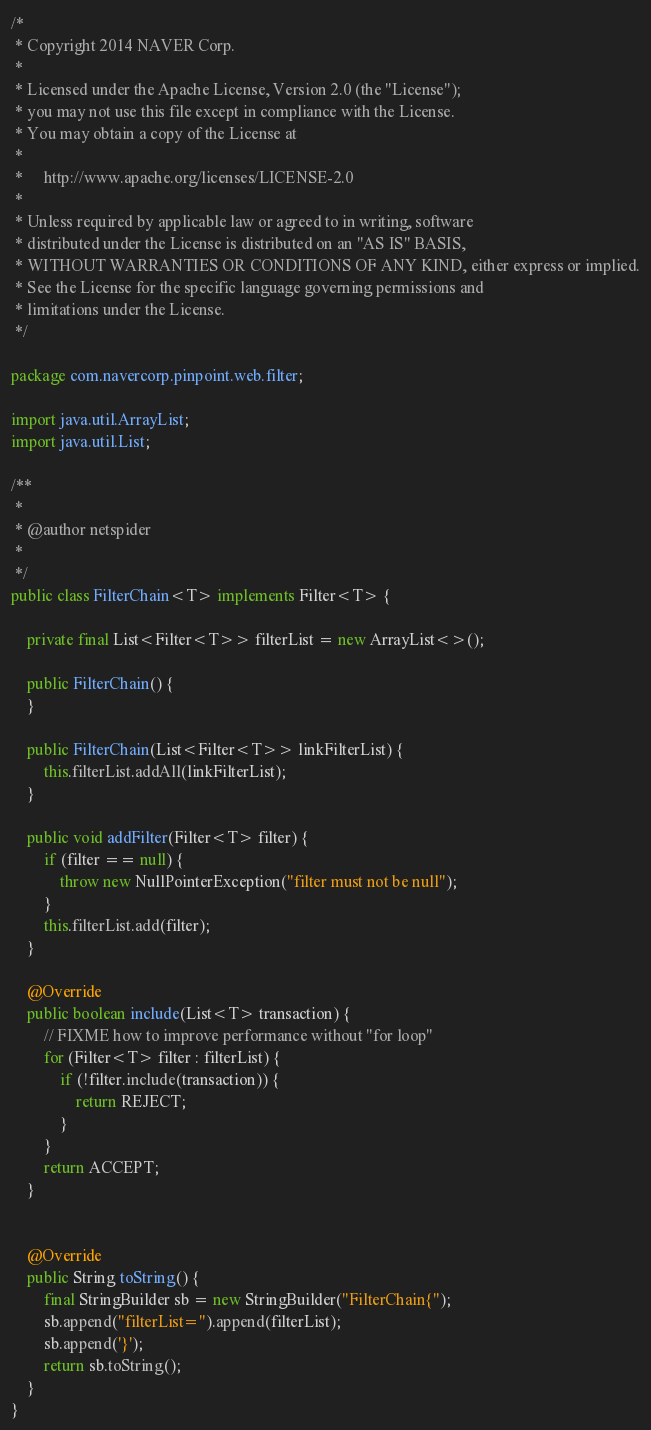<code> <loc_0><loc_0><loc_500><loc_500><_Java_>/*
 * Copyright 2014 NAVER Corp.
 *
 * Licensed under the Apache License, Version 2.0 (the "License");
 * you may not use this file except in compliance with the License.
 * You may obtain a copy of the License at
 *
 *     http://www.apache.org/licenses/LICENSE-2.0
 *
 * Unless required by applicable law or agreed to in writing, software
 * distributed under the License is distributed on an "AS IS" BASIS,
 * WITHOUT WARRANTIES OR CONDITIONS OF ANY KIND, either express or implied.
 * See the License for the specific language governing permissions and
 * limitations under the License.
 */

package com.navercorp.pinpoint.web.filter;

import java.util.ArrayList;
import java.util.List;

/**
 *
 * @author netspider
 *
 */
public class FilterChain<T> implements Filter<T> {

    private final List<Filter<T>> filterList = new ArrayList<>();

    public FilterChain() {
    }

    public FilterChain(List<Filter<T>> linkFilterList) {
        this.filterList.addAll(linkFilterList);
    }

    public void addFilter(Filter<T> filter) {
        if (filter == null) {
            throw new NullPointerException("filter must not be null");
        }
        this.filterList.add(filter);
    }

    @Override
    public boolean include(List<T> transaction) {
        // FIXME how to improve performance without "for loop"
        for (Filter<T> filter : filterList) {
            if (!filter.include(transaction)) {
                return REJECT;
            }
        }
        return ACCEPT;
    }


    @Override
    public String toString() {
        final StringBuilder sb = new StringBuilder("FilterChain{");
        sb.append("filterList=").append(filterList);
        sb.append('}');
        return sb.toString();
    }
}
</code> 